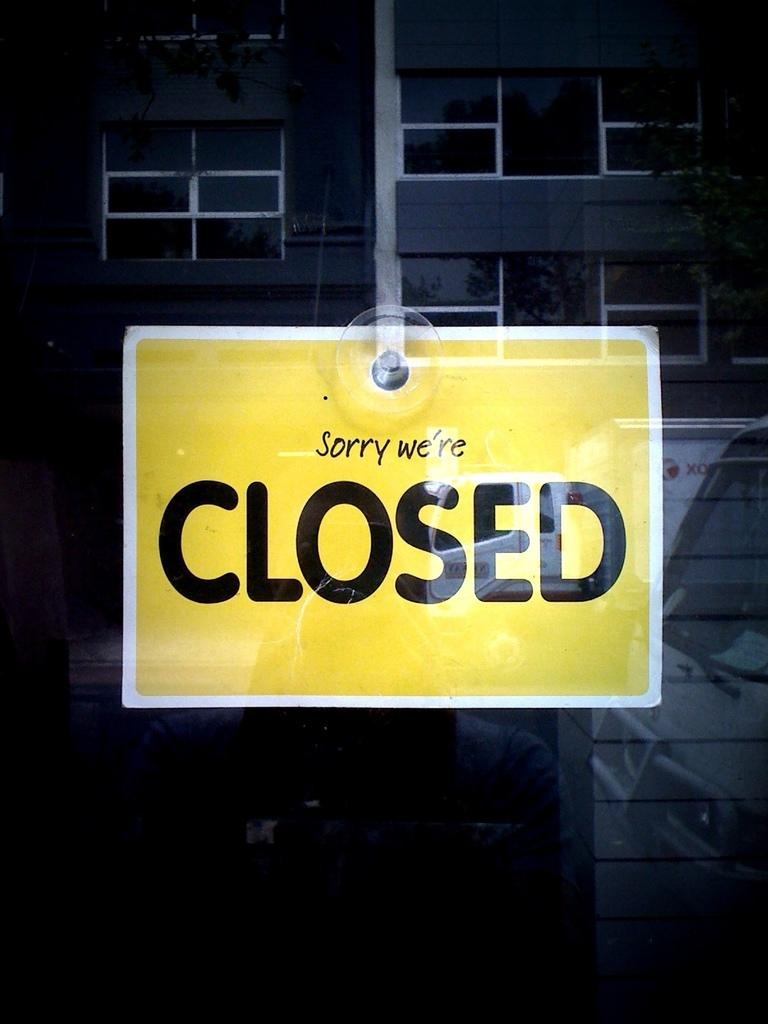What is the main object in the foreground of the image? There is a display board in the image. What can be seen in the background of the image? There is a building behind the display board. Is there a woman holding a hand in the image? There is no woman or hand present in the image; it only features a display board and a building in the background. 